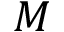<formula> <loc_0><loc_0><loc_500><loc_500>M</formula> 